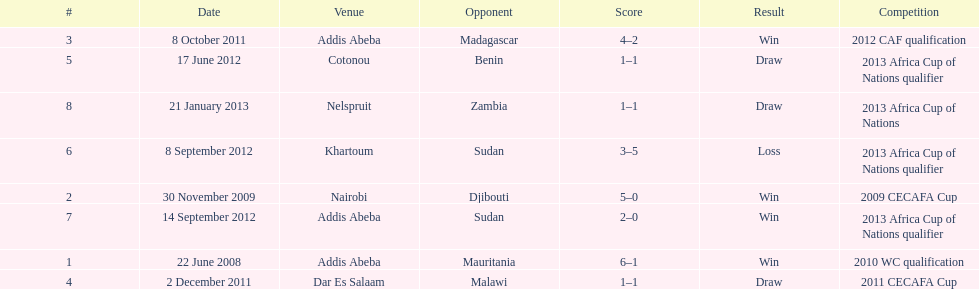What date gives was their only loss? 8 September 2012. 